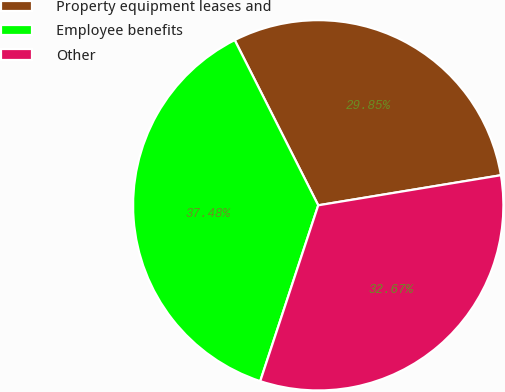Convert chart to OTSL. <chart><loc_0><loc_0><loc_500><loc_500><pie_chart><fcel>Property equipment leases and<fcel>Employee benefits<fcel>Other<nl><fcel>29.85%<fcel>37.48%<fcel>32.67%<nl></chart> 